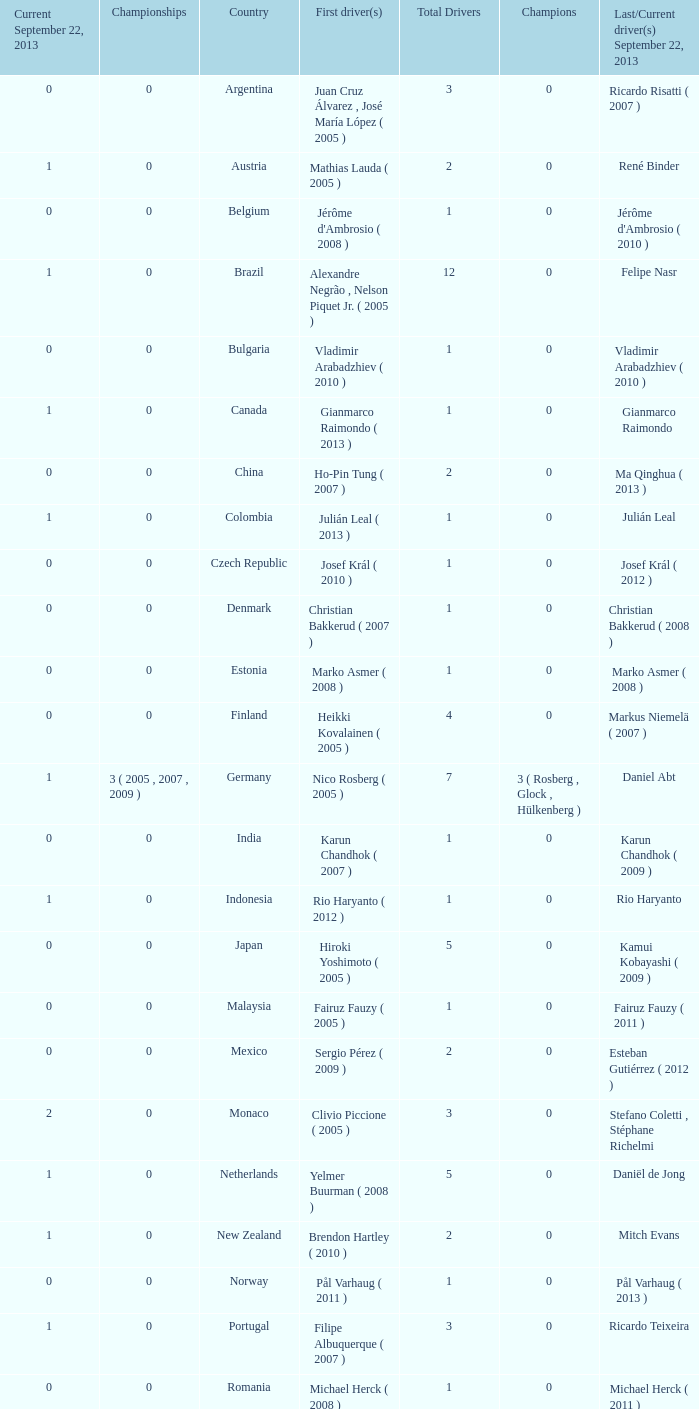How many entries are there for first driver for Canada? 1.0. 